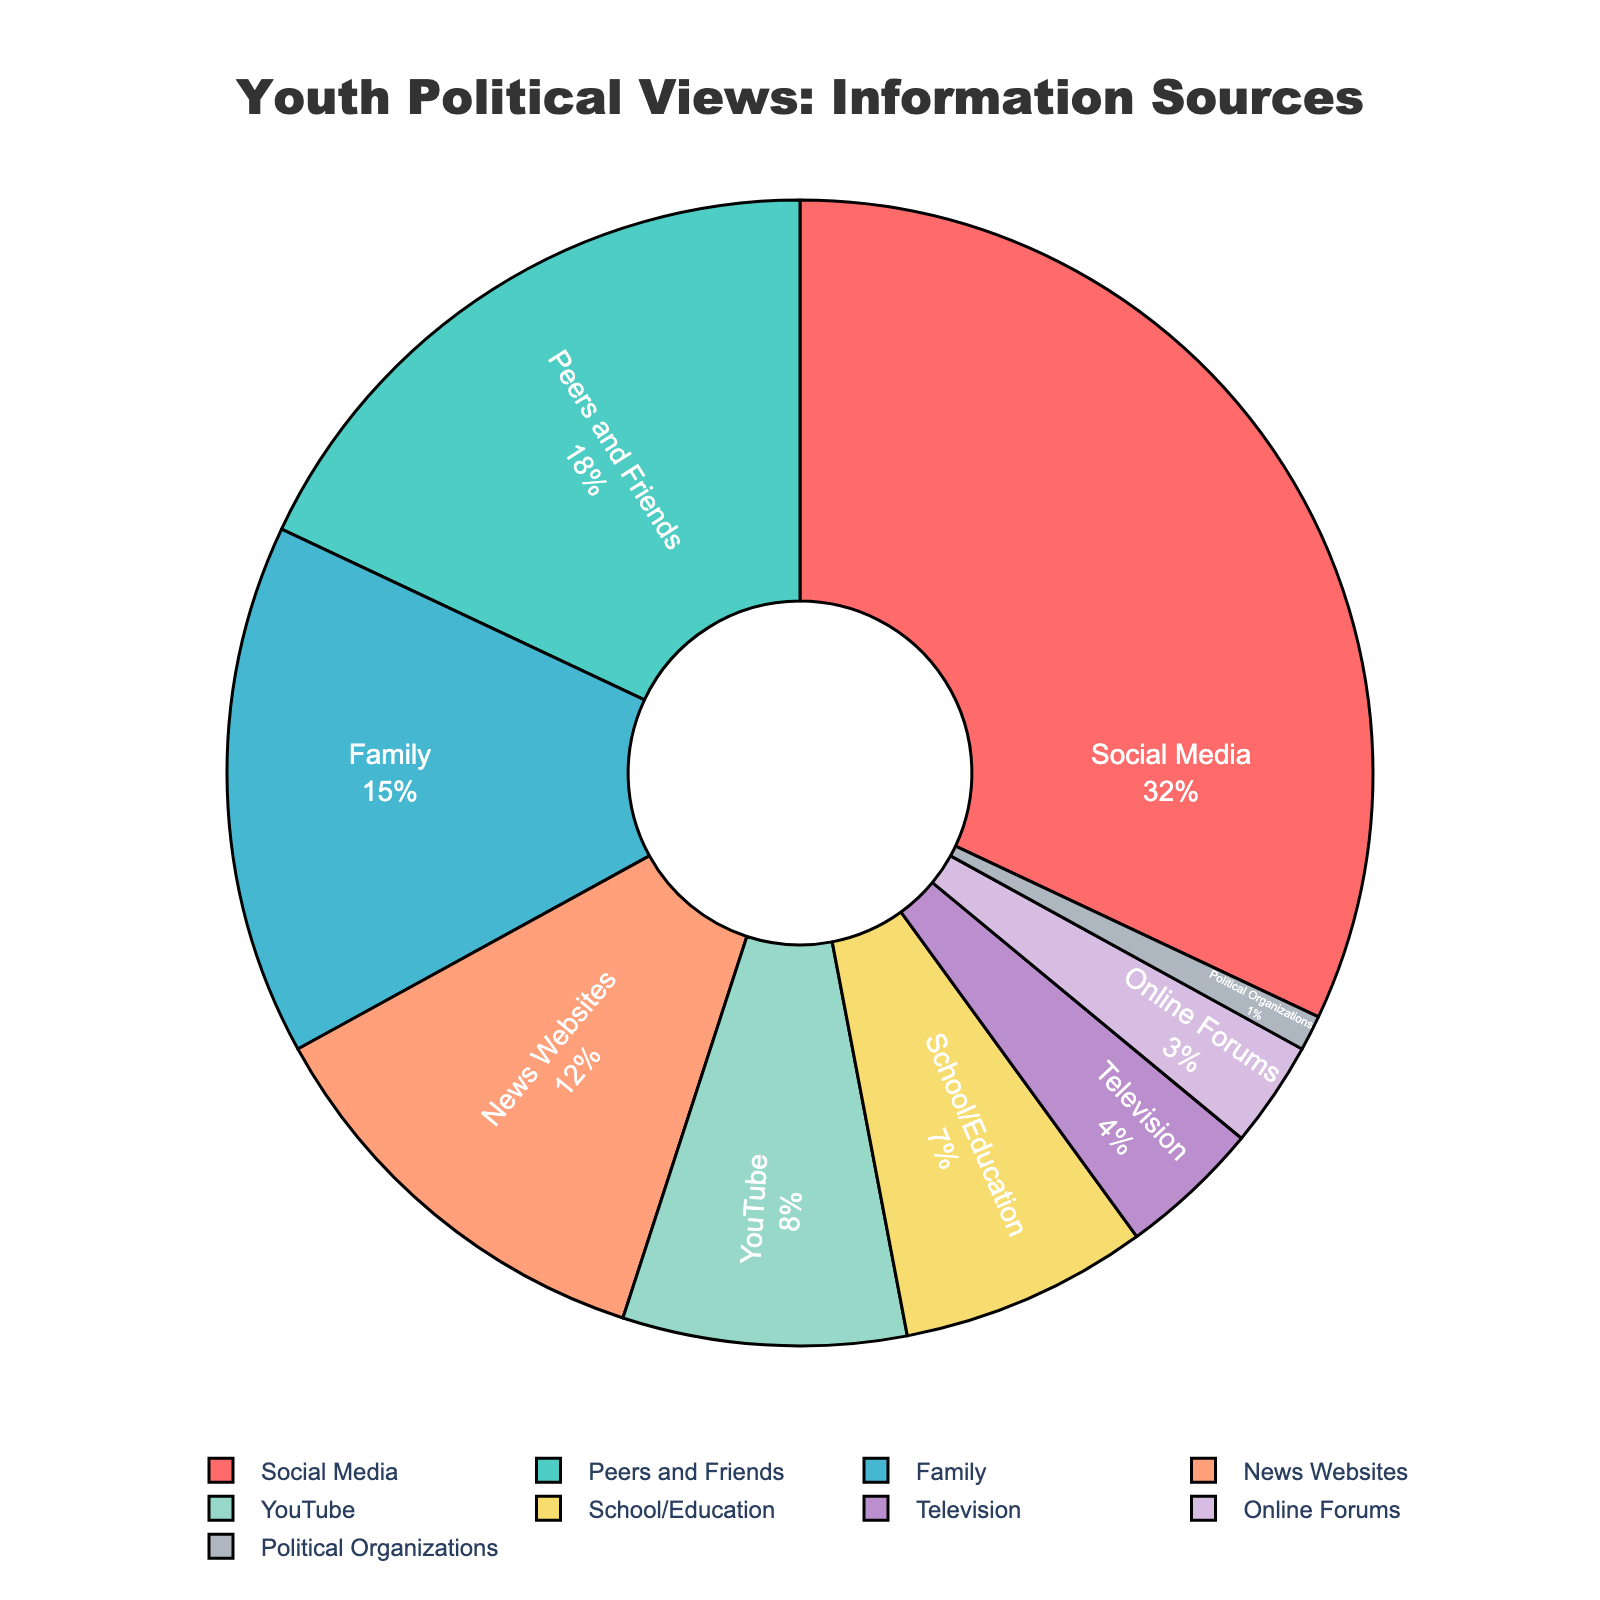What is the largest source of influence on youth political views? Social Media has the highest percentage at 32%, making it the largest source of influence on youth political views.
Answer: Social Media What is the combined percentage of influence for Family and School/Education? The percentage for Family is 15% and for School/Education is 7%. Adding these together gives 15 + 7 = 22%.
Answer: 22% Which source influences more youth political views: YouTube or Television? YouTube has an influence percentage of 8%, while Television has 4%. Hence, YouTube influences more youth political views.
Answer: YouTube What is the total percentage of influence from online sources (Social Media, YouTube, News Websites, Online Forums)? Adding the percentages for Social Media (32%), YouTube (8%), News Websites (12%), and Online Forums (3%) gives 32 + 8 + 12 + 3 = 55%.
Answer: 55% Which sources have a percentage of influence greater than 10%? The sources with percentages greater than 10% are Social Media (32%), Peers and Friends (18%), and Family (15%).
Answer: Social Media, Peers and Friends, Family How much more influential are Peers and Friends compared to Political Organizations? The percentage for Peers and Friends is 18% and for Political Organizations is 1%. The difference is 18 - 1 = 17%.
Answer: 17% What is the percentage difference between the influence of News Websites and Television? News Websites have an influence of 12% and Television has 4%. The difference is 12 - 4 = 8%.
Answer: 8% Which two sources have the closest percentages of influence, and what are those percentages? School/Education (7%) and YouTube (8%) have the closest percentages of influence, with a difference of only 1%.
Answer: School/Education (7%) and YouTube (8%) What is the average percentage of influence across all sources? To calculate the average, sum up all the percentages and divide by the number of sources: (32 + 18 + 15 + 12 + 8 + 7 + 4 + 3 + 1) / 9 = 100 / 9 ≈ 11.11%
Answer: 11.11% If Social Media's influence is reduced by half, what would be its new percentage of influence? If Social Media's influence is halved, it would be 32 / 2 = 16%.
Answer: 16% 